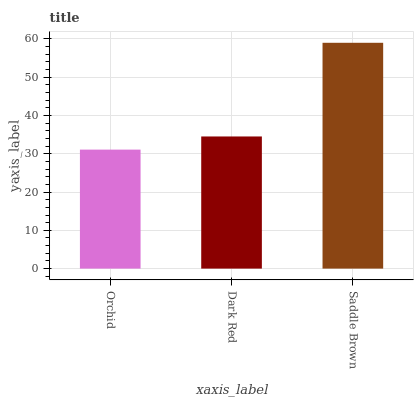Is Orchid the minimum?
Answer yes or no. Yes. Is Saddle Brown the maximum?
Answer yes or no. Yes. Is Dark Red the minimum?
Answer yes or no. No. Is Dark Red the maximum?
Answer yes or no. No. Is Dark Red greater than Orchid?
Answer yes or no. Yes. Is Orchid less than Dark Red?
Answer yes or no. Yes. Is Orchid greater than Dark Red?
Answer yes or no. No. Is Dark Red less than Orchid?
Answer yes or no. No. Is Dark Red the high median?
Answer yes or no. Yes. Is Dark Red the low median?
Answer yes or no. Yes. Is Saddle Brown the high median?
Answer yes or no. No. Is Saddle Brown the low median?
Answer yes or no. No. 